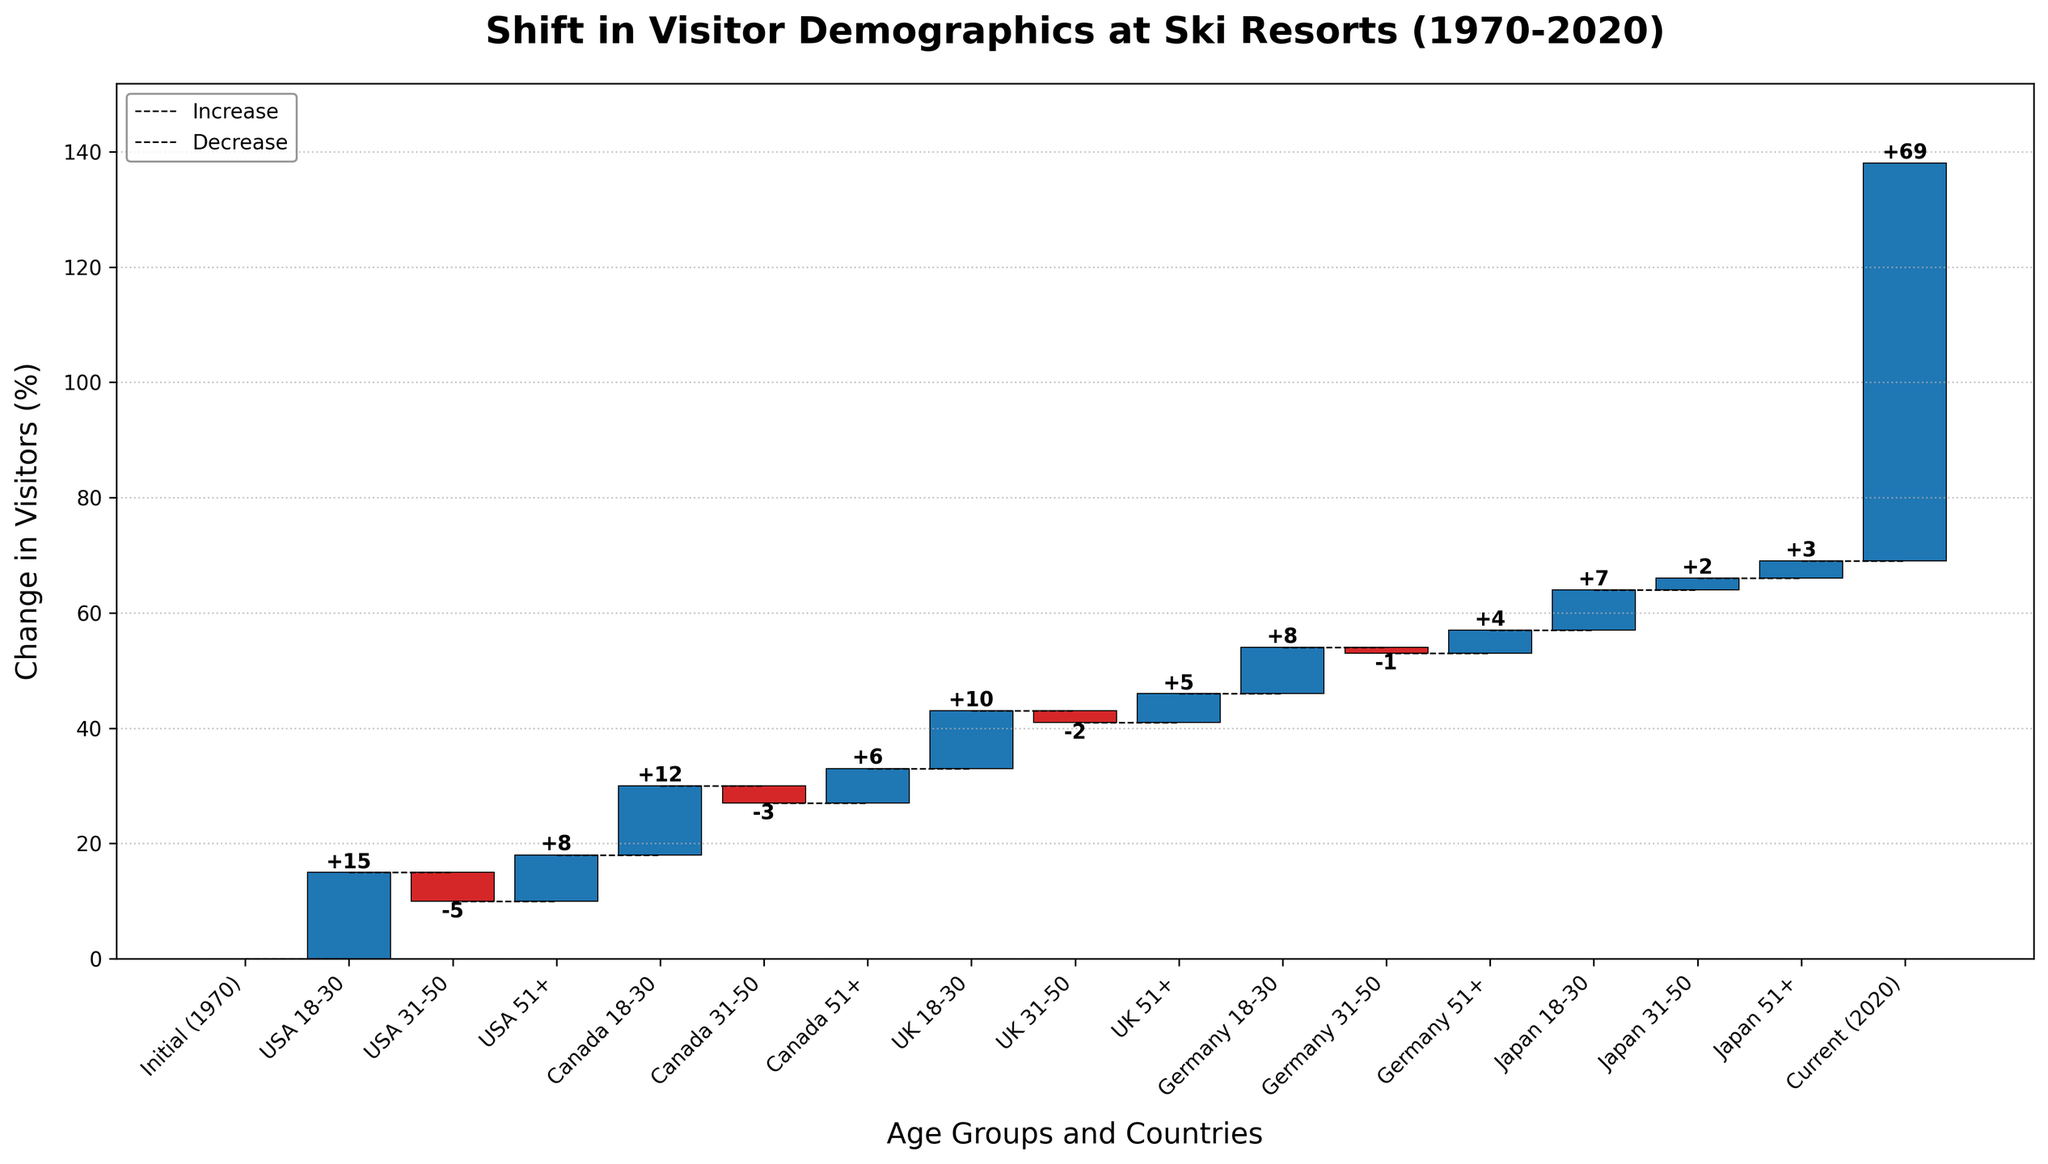what is the title of the chart? The title is usually located at the top of the chart and summarizes the main point of the visualization. In this case, it reads "Shift in Visitor Demographics at Ski Resorts (1970-2020)."
Answer: Shift in Visitor Demographics at Ski Resorts (1970-2020) What color represents an increase in visitor demographics? In a waterfall chart, different colors are used to indicate positive and negative changes. The color for increases in this chart is blue.
Answer: Blue Which age group and country had the highest increase in visitors? To find the highest increase, look for the largest positive bar. The USA 18-30 age group saw a +15% increase, which is the highest.
Answer: USA 18-30 What is the total cumulative change from 1970 to 2020? The total cumulative change can be directly read off as the final value at the "Current (2020)" point. This value is 69%.
Answer: 69% How did the visitor demographics for the 31-50 age group change in Canada? Find the bar corresponding to Canada 31-50. The change is represented as -3%, indicating a decline.
Answer: -3% What is the total increase in visitors for the 18-30 age group across all countries? Sum the values for the 18-30 age group across all countries (USA 15 + Canada 12 + UK 10 + Germany 8 + Japan 7 = 52%). Therefore, the total increase is 52%.
Answer: 52% Which country experienced the smallest increase in the 51+ age group? To determine this, compare the values for the 51+ age group across all countries. Japan had the smallest increase at +3%.
Answer: Japan What was the overall trend for the 31-50 age group visitors across all countries? Evaluate the change for the 31-50 age group for each country. USA -5, Canada -3, UK -2, Germany -1, Japan +2. Adding these values yields -9 + 2 = -7%, indicating an overall decline.
Answer: Decline How did the 18-30 age group in Germany change, and how does it compare to Japan? The change for Germany's 18-30 age group is +8%, and for Japan's 18-30 age group, it's +7%. Germany saw a larger increase.
Answer: Germany saw a larger increase Summarize the overall trend in visitor demographics for the UK. Observing the UK’s changes: 18-30 +10%, 31-50 -2%, and 51+ +5%. Despite the decline in the 31-50 age group, the overall trend shows an increase in visitors, mainly led by the 18-30 group.
Answer: Increase 